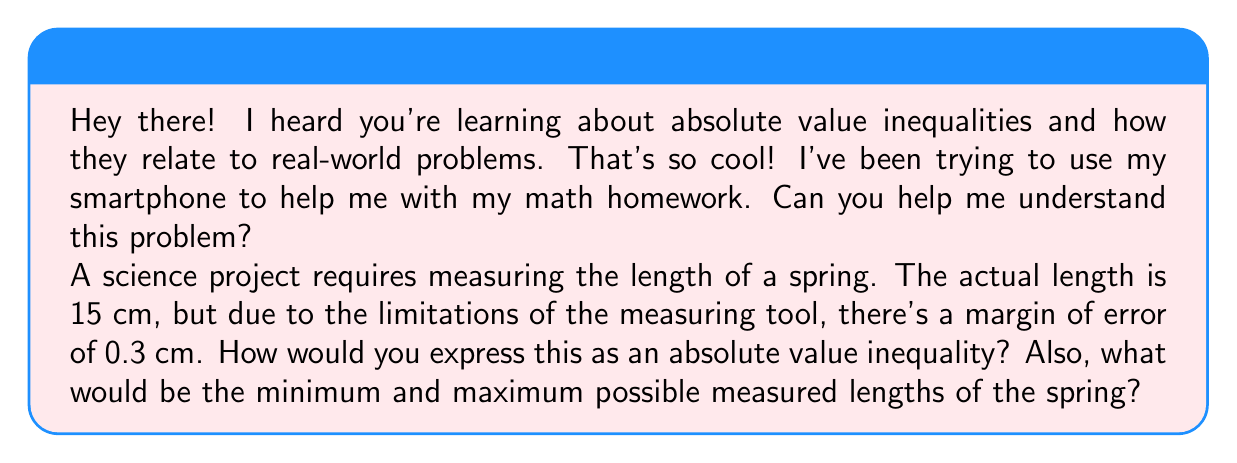What is the answer to this math problem? Sure! I'd be happy to help you understand this problem. Let's break it down step-by-step:

1) First, let's define our variable. Let $x$ be the measured length of the spring.

2) We know the actual length is 15 cm, and the margin of error is 0.3 cm. This means the measured length can be off by at most 0.3 cm in either direction.

3) We can express this using an absolute value inequality:

   $$|x - 15| \leq 0.3$$

   This reads as "the absolute difference between x and 15 is less than or equal to 0.3".

4) To find the minimum and maximum possible measured lengths, we can solve this inequality:

   $$-0.3 \leq x - 15 \leq 0.3$$

5) Add 15 to all parts of the inequality:

   $$14.7 \leq x \leq 15.3$$

6) Therefore, the minimum possible measured length is 14.7 cm, and the maximum is 15.3 cm.

You can use your smartphone's calculator to check these calculations! This is a great way to incorporate technology into your learning.
Answer: The absolute value inequality is $|x - 15| \leq 0.3$, where $x$ is the measured length in cm.
The minimum possible measured length is 14.7 cm.
The maximum possible measured length is 15.3 cm. 